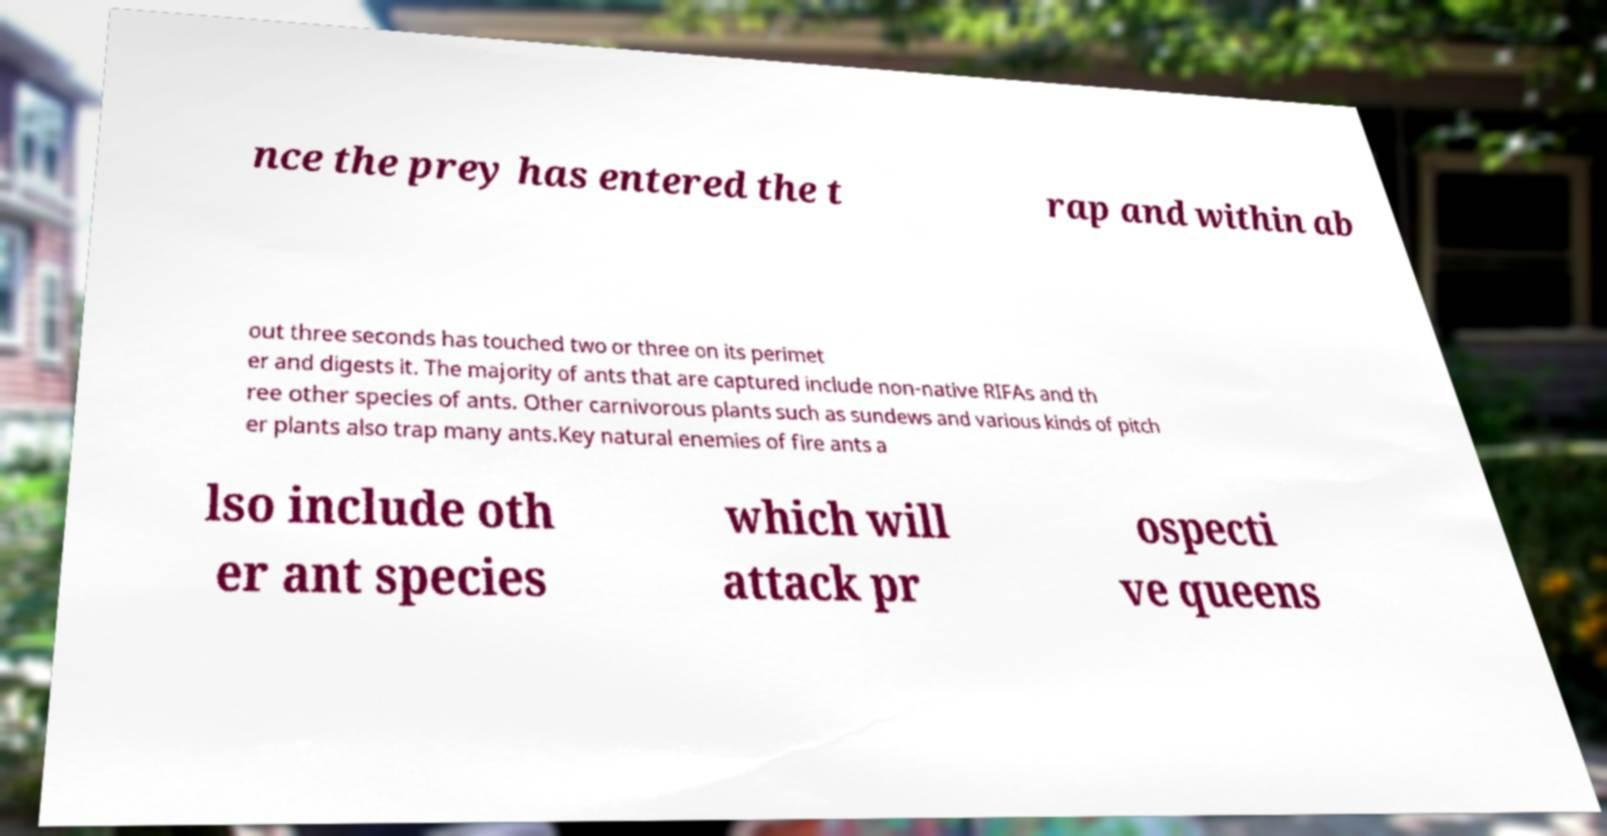There's text embedded in this image that I need extracted. Can you transcribe it verbatim? nce the prey has entered the t rap and within ab out three seconds has touched two or three on its perimet er and digests it. The majority of ants that are captured include non-native RIFAs and th ree other species of ants. Other carnivorous plants such as sundews and various kinds of pitch er plants also trap many ants.Key natural enemies of fire ants a lso include oth er ant species which will attack pr ospecti ve queens 